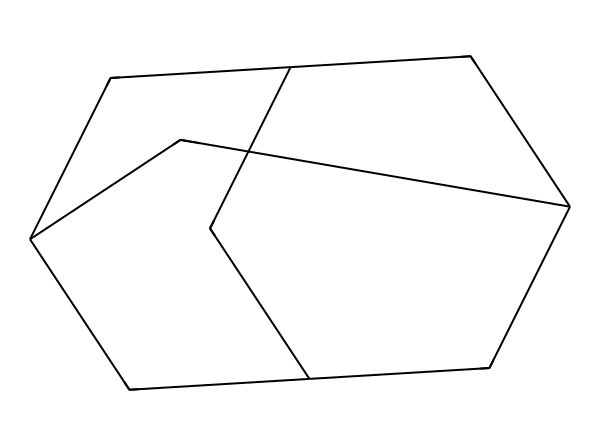What is the molecular formula of adamantane? To determine the molecular formula, count the number of carbon (C) and hydrogen (H) atoms in the structure. The structure has 10 carbon atoms and 16 hydrogen atoms. Therefore, the molecular formula is C10H16.
Answer: C10H16 How many carbon atoms are in adamantane? The SMILES representation indicates there are 10 'C' symbols present, signifying 10 carbon atoms in the structure.
Answer: 10 What type of compound is adamantane? Adamantane is categorized as a cage compound due to its unique three-dimensional structure where the carbon atoms are arranged in a polycyclic configuration, forming a cage-like structure.
Answer: cage compound What is the total number of hydrogen atoms in the molecule? By counting the hydrogen atoms represented in the SMILES notation or understanding the general valency of carbon (which forms four bonds), we can ascertain that there are 16 hydrogen atoms connected to the carbon framework in adamantane.
Answer: 16 Does adamantane contain any nitrogen or oxygen atoms? Based on the SMILES representation, there are no symbols representing nitrogen or oxygen (N or O) in the structure, indicating that adamantane is purely made of carbon and hydrogen atoms.
Answer: no What is the symmetry of the adamantane molecule? Adamantane has a highly symmetrical structure characterized by its tetrahedral sections and overall icosahedral symmetry, allowing it to maintain a consistent spatial arrangement of atoms.
Answer: icosahedral How does the structure of adamantane influence its stability? The compact, densely packed cage structure minimizes strain on bond angles and maximizes van der Waals interactions, contributing to its unique stability compared to other hydrocarbons of similar size.
Answer: increases stability 